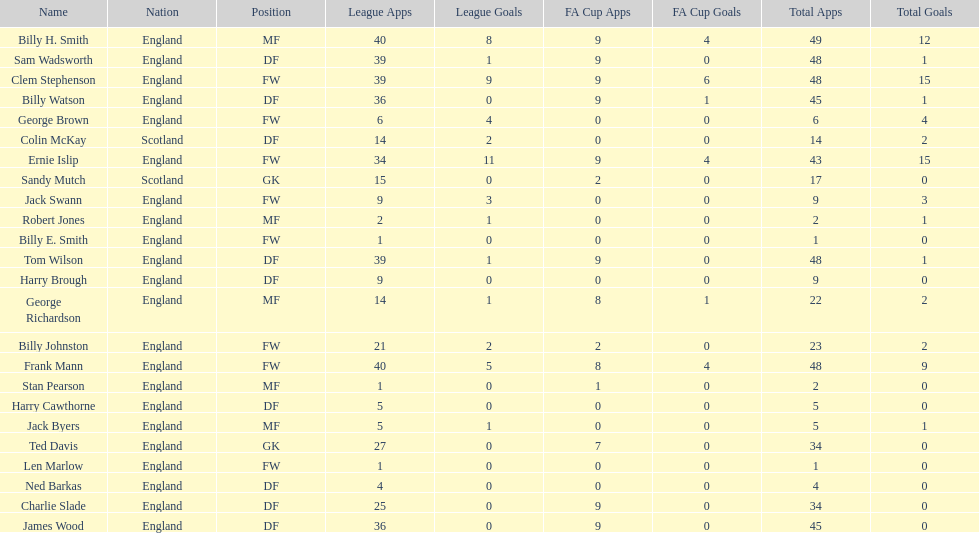Could you parse the entire table? {'header': ['Name', 'Nation', 'Position', 'League Apps', 'League Goals', 'FA Cup Apps', 'FA Cup Goals', 'Total Apps', 'Total Goals'], 'rows': [['Billy H. Smith', 'England', 'MF', '40', '8', '9', '4', '49', '12'], ['Sam Wadsworth', 'England', 'DF', '39', '1', '9', '0', '48', '1'], ['Clem Stephenson', 'England', 'FW', '39', '9', '9', '6', '48', '15'], ['Billy Watson', 'England', 'DF', '36', '0', '9', '1', '45', '1'], ['George Brown', 'England', 'FW', '6', '4', '0', '0', '6', '4'], ['Colin McKay', 'Scotland', 'DF', '14', '2', '0', '0', '14', '2'], ['Ernie Islip', 'England', 'FW', '34', '11', '9', '4', '43', '15'], ['Sandy Mutch', 'Scotland', 'GK', '15', '0', '2', '0', '17', '0'], ['Jack Swann', 'England', 'FW', '9', '3', '0', '0', '9', '3'], ['Robert Jones', 'England', 'MF', '2', '1', '0', '0', '2', '1'], ['Billy E. Smith', 'England', 'FW', '1', '0', '0', '0', '1', '0'], ['Tom Wilson', 'England', 'DF', '39', '1', '9', '0', '48', '1'], ['Harry Brough', 'England', 'DF', '9', '0', '0', '0', '9', '0'], ['George Richardson', 'England', 'MF', '14', '1', '8', '1', '22', '2'], ['Billy Johnston', 'England', 'FW', '21', '2', '2', '0', '23', '2'], ['Frank Mann', 'England', 'FW', '40', '5', '8', '4', '48', '9'], ['Stan Pearson', 'England', 'MF', '1', '0', '1', '0', '2', '0'], ['Harry Cawthorne', 'England', 'DF', '5', '0', '0', '0', '5', '0'], ['Jack Byers', 'England', 'MF', '5', '1', '0', '0', '5', '1'], ['Ted Davis', 'England', 'GK', '27', '0', '7', '0', '34', '0'], ['Len Marlow', 'England', 'FW', '1', '0', '0', '0', '1', '0'], ['Ned Barkas', 'England', 'DF', '4', '0', '0', '0', '4', '0'], ['Charlie Slade', 'England', 'DF', '25', '0', '9', '0', '34', '0'], ['James Wood', 'England', 'DF', '36', '0', '9', '0', '45', '0']]} What is the average number of scotland's total apps? 15.5. 